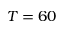Convert formula to latex. <formula><loc_0><loc_0><loc_500><loc_500>T = 6 0</formula> 